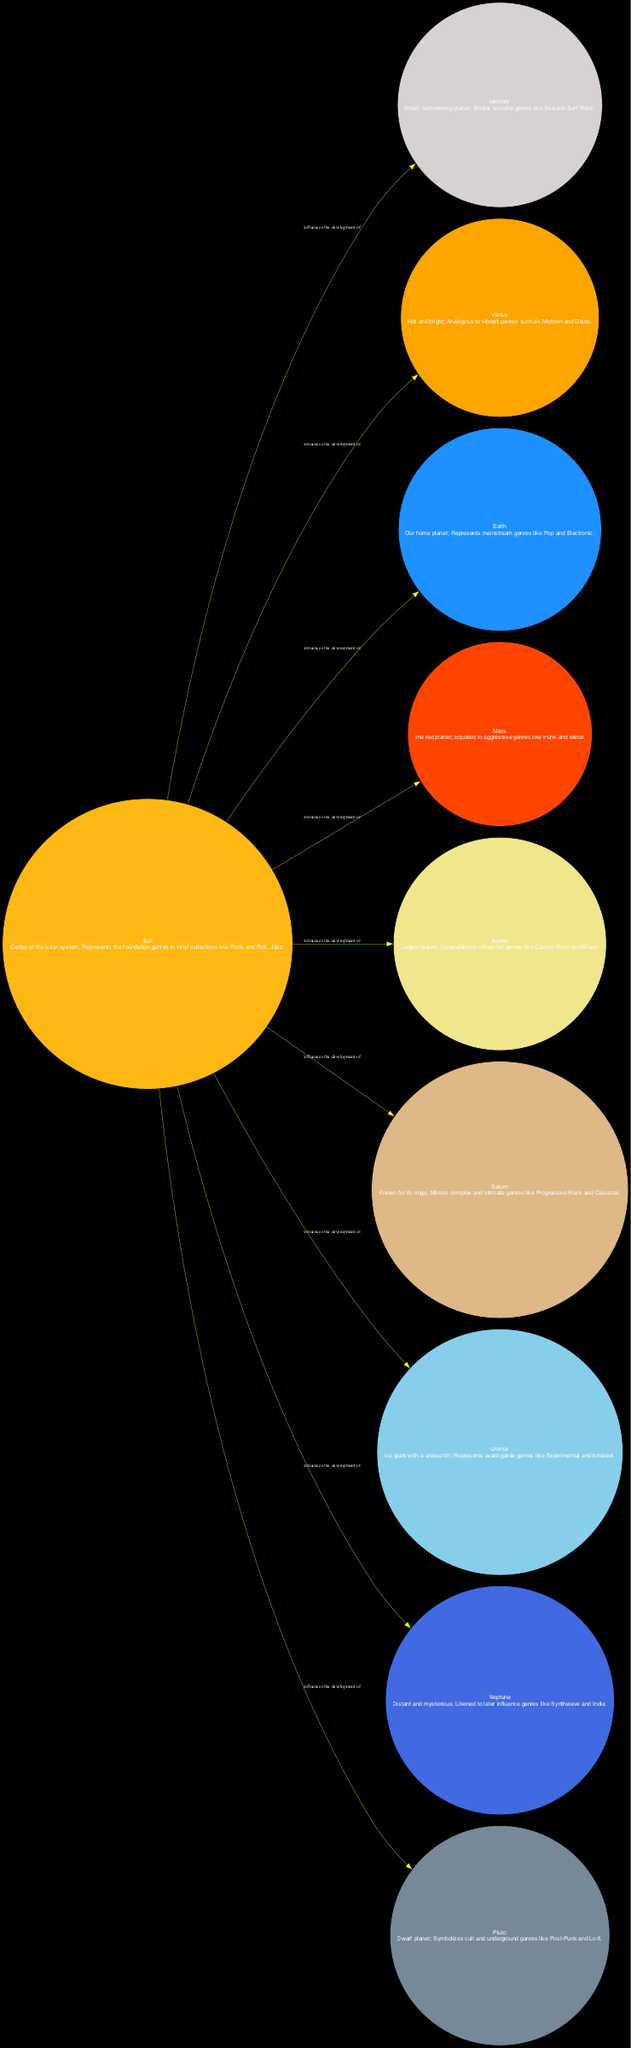What genre does Venus represent? According to the diagram, Venus is described as "Hot and bright; Analogous to vibrant genres such as Motown and Disco." Therefore, the genre represented by Venus is Motown and Disco.
Answer: Motown and Disco How many planets are influenced by the Sun? The diagram shows that there are eight planets, each connected to the Sun with the relation "Influences the development of." By counting them in the diagram, we find there are eight influences.
Answer: Eight Which planet is analogous to aggressive genres? The description for Mars identifies it as "The red planet; Equated to aggressive genres like Punk and Metal." Thus, Mars is the planet that represents aggressive genres.
Answer: Mars What is the relationship between the Sun and Jupiter? The diagram denotes an edge from the Sun to Jupiter with the relation "Influences the development of." This indicates that the Sun plays a significant role in the evolution of the genre represented by Jupiter.
Answer: Influences the development of Which planet corresponds to complex and intricate genres? The description of Saturn mentions "Mirrors complex and intricate genres like Progressive Rock and Classical." Thus, Saturn corresponds to these types of genres.
Answer: Saturn Which genre does Pluto symbolize? Pluto is described as "Dwarf planet; Symbolizes cult and underground genres like Post-Punk and Lo-fi." Therefore, the genre that Pluto symbolizes is cult and underground genres.
Answer: Cult and underground genres What are the foundations of genres in vinyl collections represented by the Sun? The Sun is described as the "Center of the solar system; Represents the foundation genres in vinyl collections like Rock and Roll, Jazz." Thus, these are the foundational genres.
Answer: Rock and Roll, Jazz How do the characteristics of Mercury compare to the overall genre theme? Mercury represents "Small, fast-moving planet; Similar to niche genres like Ska and Surf Rock." This shows that Mercury embodies the idea of niche and perhaps lesser-known genres compared to more mainstream scenes.
Answer: Niche genres Which planet is represented as distant and mysterious? According to the description, Neptune is defined as "Distant and mysterious; Likened to later influence genres like Synthwave and Indie." This clearly identifies Neptune as the distant and mysterious planet.
Answer: Neptune 